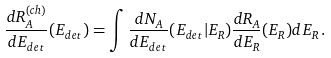<formula> <loc_0><loc_0><loc_500><loc_500>\frac { d R ^ { ( c h ) } _ { A } } { d E _ { d e t } } ( E _ { d e t } ) = \int \frac { d N _ { A } } { d E _ { d e t } } ( E _ { d e t } | E _ { R } ) \frac { d R _ { A } } { d E _ { R } } ( E _ { R } ) d E _ { R } \, .</formula> 